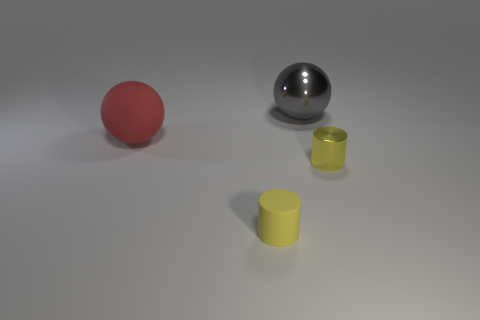Add 3 metallic cubes. How many objects exist? 7 Subtract 1 balls. How many balls are left? 1 Add 1 big metallic balls. How many big metallic balls exist? 2 Subtract 1 red spheres. How many objects are left? 3 Subtract all cyan balls. Subtract all blue cylinders. How many balls are left? 2 Subtract all purple blocks. How many gray spheres are left? 1 Subtract all tiny cyan cylinders. Subtract all big matte objects. How many objects are left? 3 Add 1 matte things. How many matte things are left? 3 